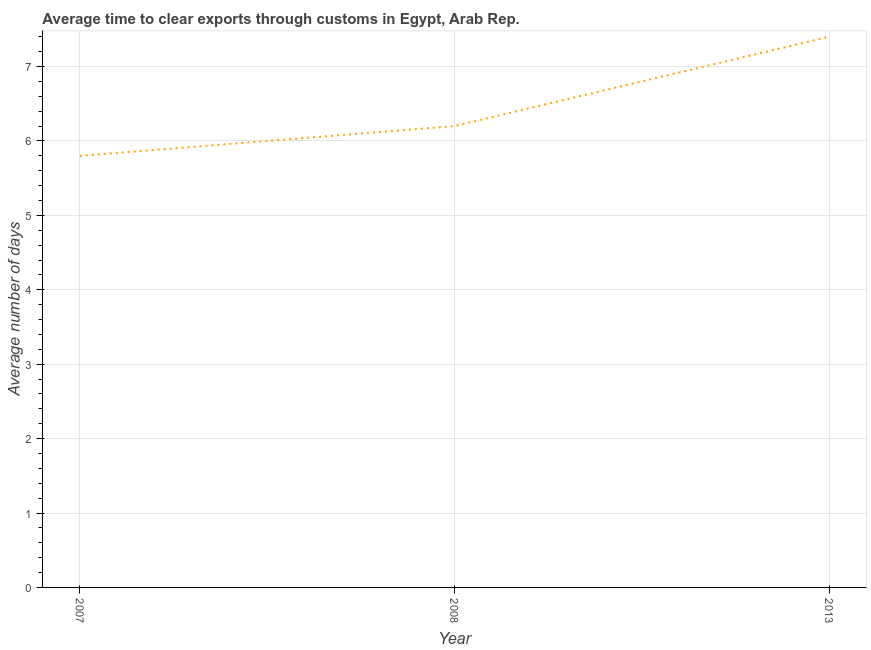Across all years, what is the maximum time to clear exports through customs?
Keep it short and to the point. 7.4. What is the difference between the time to clear exports through customs in 2008 and 2013?
Make the answer very short. -1.2. What is the average time to clear exports through customs per year?
Offer a very short reply. 6.47. What is the median time to clear exports through customs?
Your response must be concise. 6.2. What is the ratio of the time to clear exports through customs in 2007 to that in 2013?
Provide a succinct answer. 0.78. Is the time to clear exports through customs in 2007 less than that in 2008?
Give a very brief answer. Yes. What is the difference between the highest and the second highest time to clear exports through customs?
Ensure brevity in your answer.  1.2. What is the difference between the highest and the lowest time to clear exports through customs?
Your response must be concise. 1.6. How many years are there in the graph?
Make the answer very short. 3. What is the difference between two consecutive major ticks on the Y-axis?
Keep it short and to the point. 1. Are the values on the major ticks of Y-axis written in scientific E-notation?
Give a very brief answer. No. Does the graph contain any zero values?
Your answer should be very brief. No. Does the graph contain grids?
Keep it short and to the point. Yes. What is the title of the graph?
Provide a succinct answer. Average time to clear exports through customs in Egypt, Arab Rep. What is the label or title of the Y-axis?
Make the answer very short. Average number of days. What is the Average number of days of 2013?
Keep it short and to the point. 7.4. What is the difference between the Average number of days in 2007 and 2008?
Offer a terse response. -0.4. What is the difference between the Average number of days in 2007 and 2013?
Provide a succinct answer. -1.6. What is the difference between the Average number of days in 2008 and 2013?
Make the answer very short. -1.2. What is the ratio of the Average number of days in 2007 to that in 2008?
Make the answer very short. 0.94. What is the ratio of the Average number of days in 2007 to that in 2013?
Provide a short and direct response. 0.78. What is the ratio of the Average number of days in 2008 to that in 2013?
Keep it short and to the point. 0.84. 